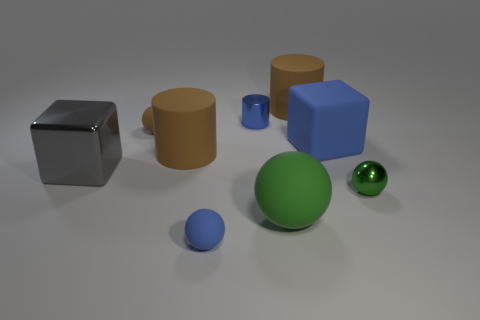There is a rubber cube; does it have the same color as the metal thing that is behind the big gray metallic block?
Offer a terse response. Yes. Is there a object that has the same color as the large matte cube?
Give a very brief answer. Yes. What is the material of the ball that is the same color as the matte block?
Give a very brief answer. Rubber. What material is the big blue block?
Ensure brevity in your answer.  Rubber. What number of big brown cylinders are on the left side of the big rubber ball?
Make the answer very short. 1. Is the tiny ball to the right of the big rubber cube made of the same material as the big blue cube?
Give a very brief answer. No. How many big brown things have the same shape as the blue shiny thing?
Your answer should be compact. 2. How many tiny objects are either brown things or green spheres?
Make the answer very short. 2. There is a matte cylinder on the right side of the tiny metallic cylinder; is its color the same as the big ball?
Ensure brevity in your answer.  No. Do the sphere that is behind the big rubber cube and the metallic object behind the gray block have the same color?
Your response must be concise. No. 